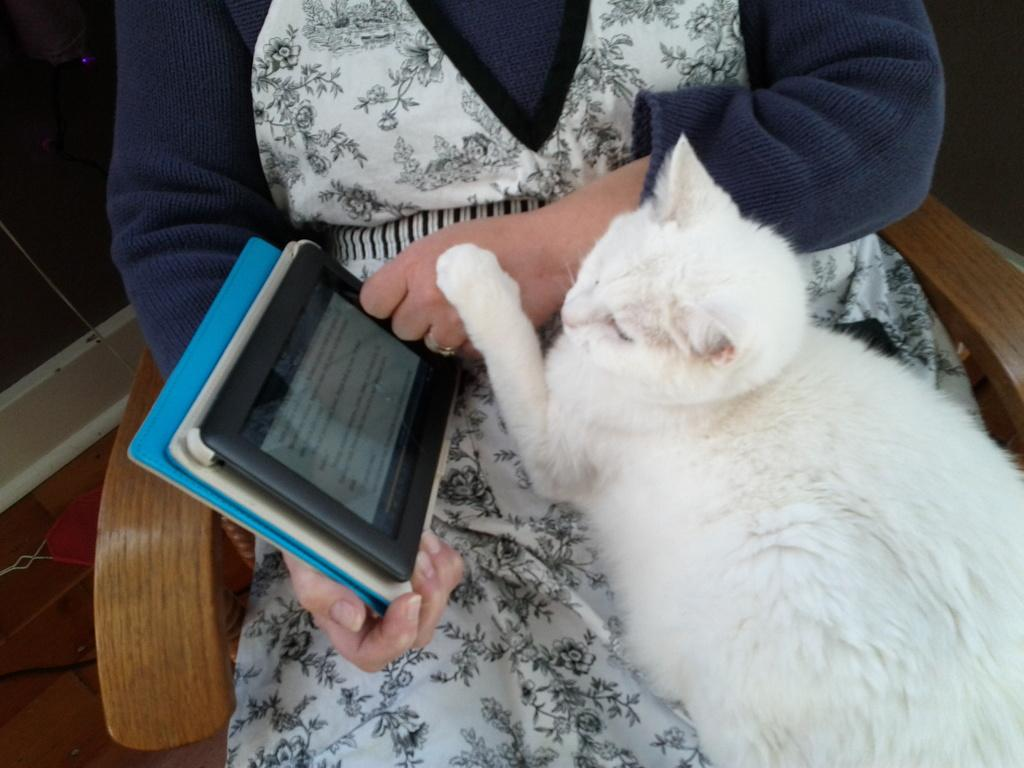What is the person in the image doing? The person is sitting on a chair in the image. What is the person holding in the image? The person is holding a tab. What type of animal can be seen in the image? There is a cat in the image. Where is the cat located in relation to the person? The cat is on the person. What type of actor is performing in the image? There is no actor or performance present in the image; it features a person sitting on a chair and holding a tab, with a cat on them. What type of band is playing in the background of the image? There is no band or music present in the image; it features a person sitting on a chair and holding a tab, with a cat on them. 